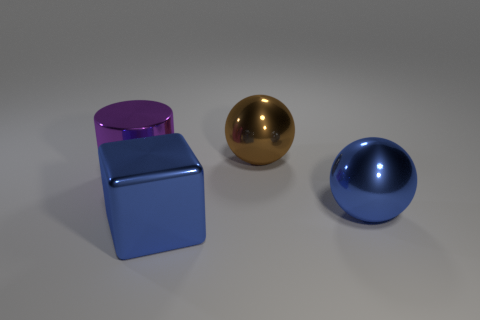What number of big things are either brown metallic objects or blue metallic objects?
Offer a very short reply. 3. Is there a rubber cube that has the same size as the purple cylinder?
Provide a short and direct response. No. There is a big metallic thing that is left of the large blue object that is to the left of the shiny object behind the large purple object; what color is it?
Provide a succinct answer. Purple. Do the large purple object and the object behind the big purple cylinder have the same material?
Give a very brief answer. Yes. There is another thing that is the same shape as the brown thing; what is its size?
Your response must be concise. Large. Are there the same number of big metal objects that are left of the big block and big purple metallic objects that are to the right of the large cylinder?
Provide a succinct answer. No. What number of other objects are the same material as the large brown sphere?
Offer a very short reply. 3. Are there an equal number of big blue objects in front of the brown metal sphere and balls?
Your answer should be compact. Yes. What shape is the object that is right of the brown thing?
Offer a very short reply. Sphere. Is there any other thing that is the same shape as the large purple object?
Give a very brief answer. No. 